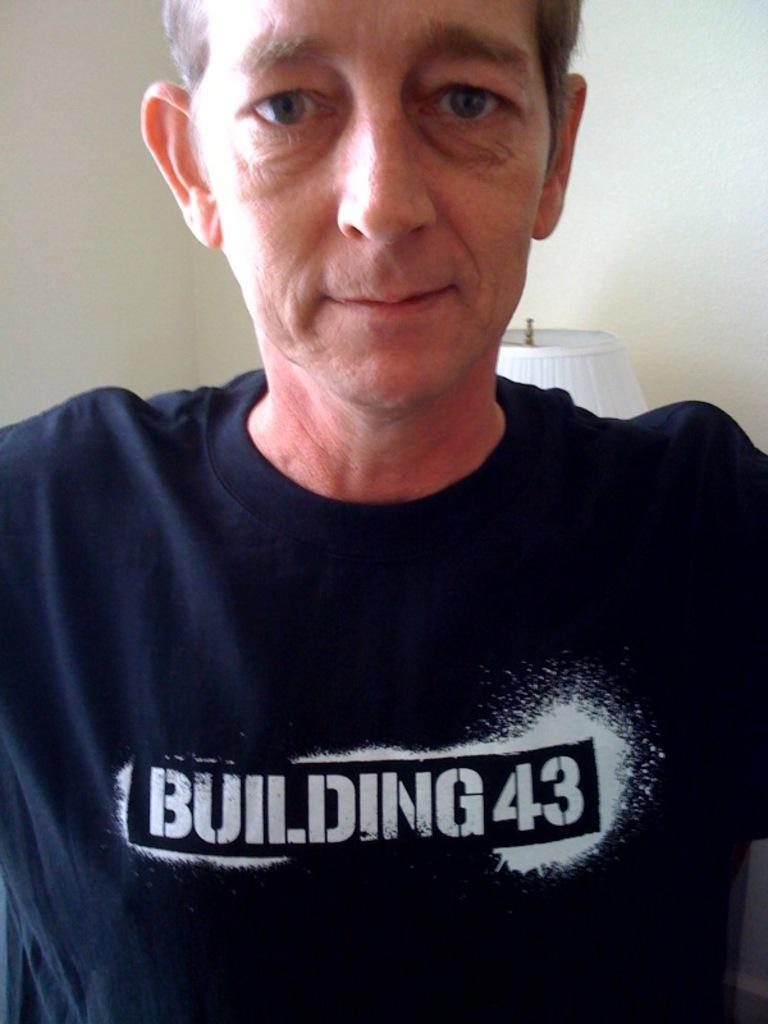How many people are in the image? There is one person in the image. What can be seen in the background of the image? There is a wall and a lamp in the background of the image. What grade is the person in the image currently studying? There is no information about the person's grade or education level in the image. 